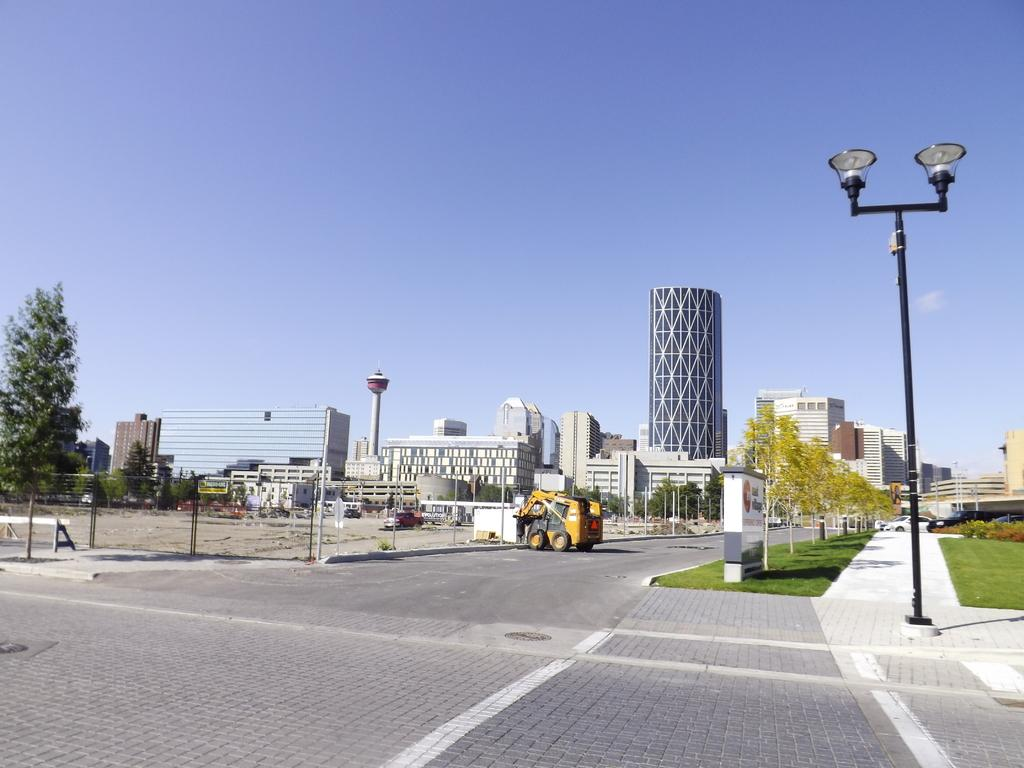What type of vegetation is present on the ground in the image? There is grass on the ground in the image. What other natural elements can be seen in the image? There are trees in the image. What type of artificial lighting is present in the image? Street lights are present in the image. What type of man-made structures can be seen in the image? There are buildings and a tower in the image. What type of transportation is visible in the image? Vehicles are visible in the image. What else can be seen in the image besides the mentioned elements? Other objects are present in the image. What part of the natural environment is visible in the image? The sky is visible in the image. What type of thrill ride can be seen in the image? There is no thrill ride present in the image. What type of tub is visible in the image? There is no tub present in the image. 